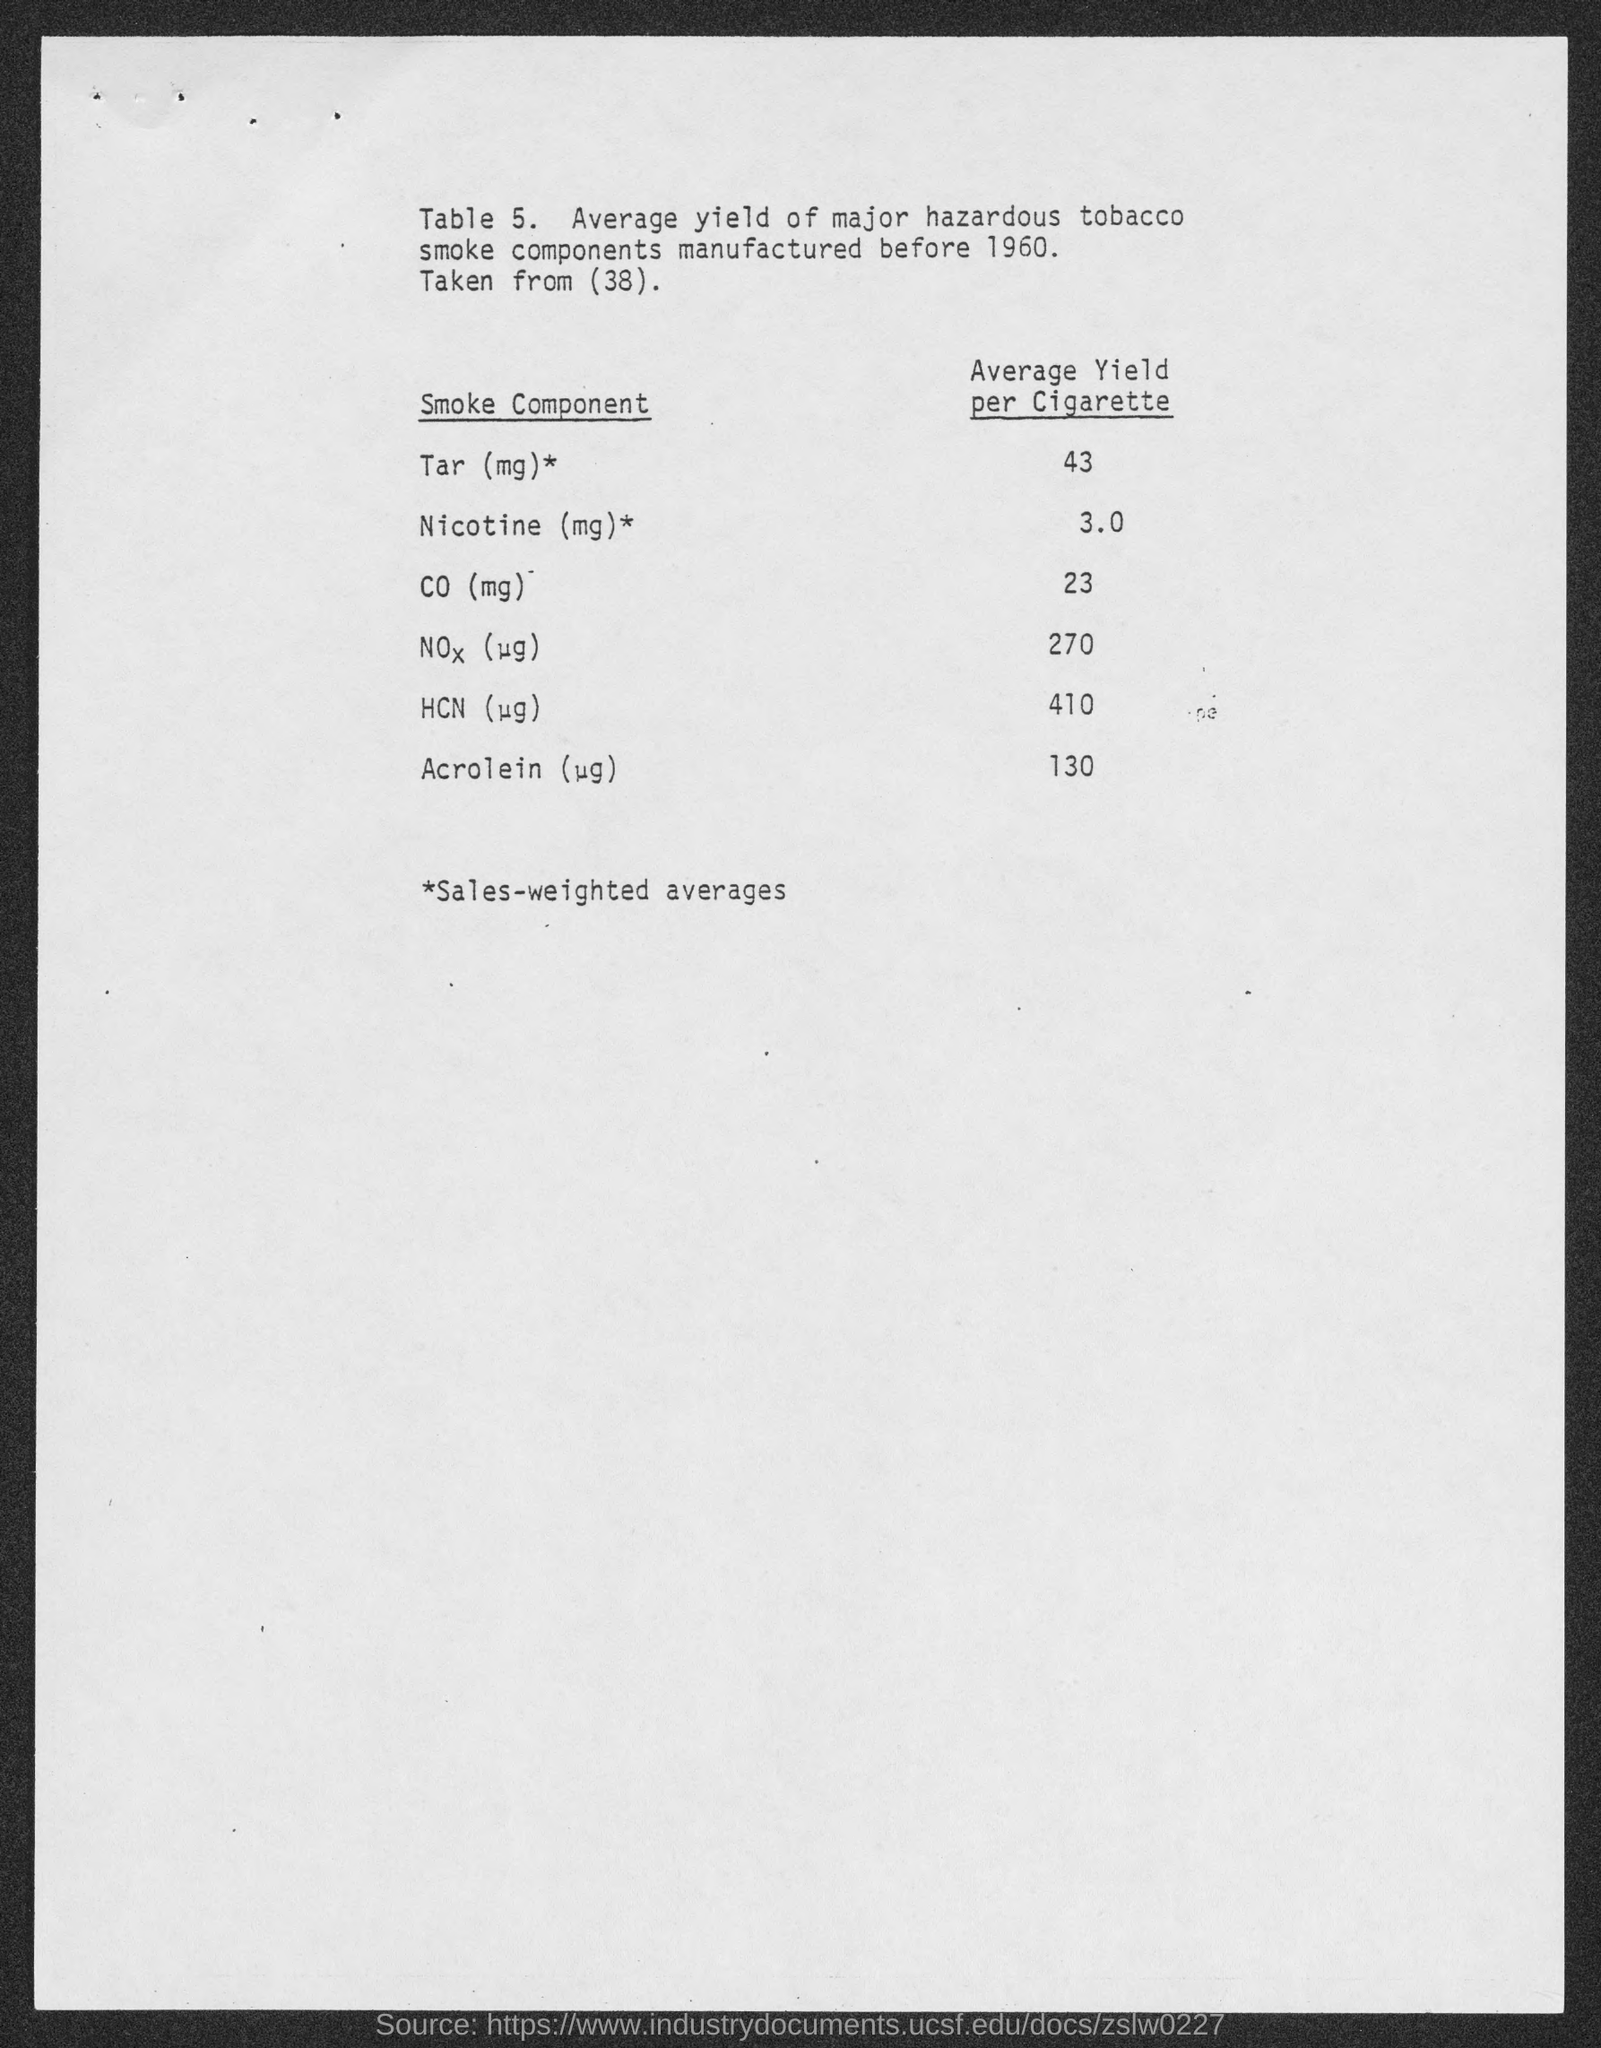Outline some significant characteristics in this image. According to information provided, the average yield of CO (mg) per cigarette manufactured before 1960 was 23 milligrams. Table 5 provides information about the average yield of major hazardous tobacco smoke components that were manufactured before 1960. On average, each cigarette manufactured before 1960 yielded approximately 43 milligrams of tar. 